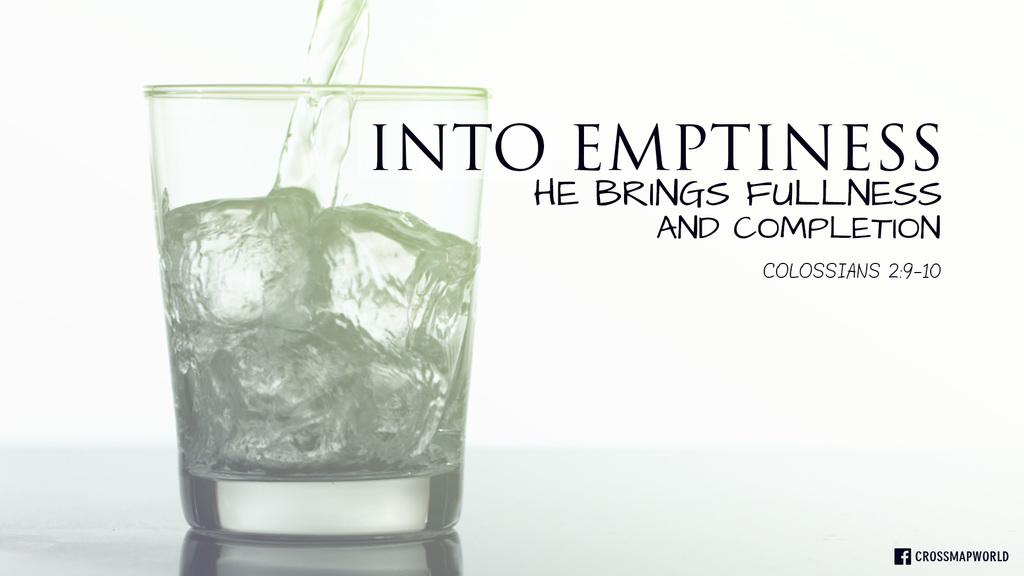<image>
Offer a succinct explanation of the picture presented. Cup of alcohol next to a saying from the Colossians. 